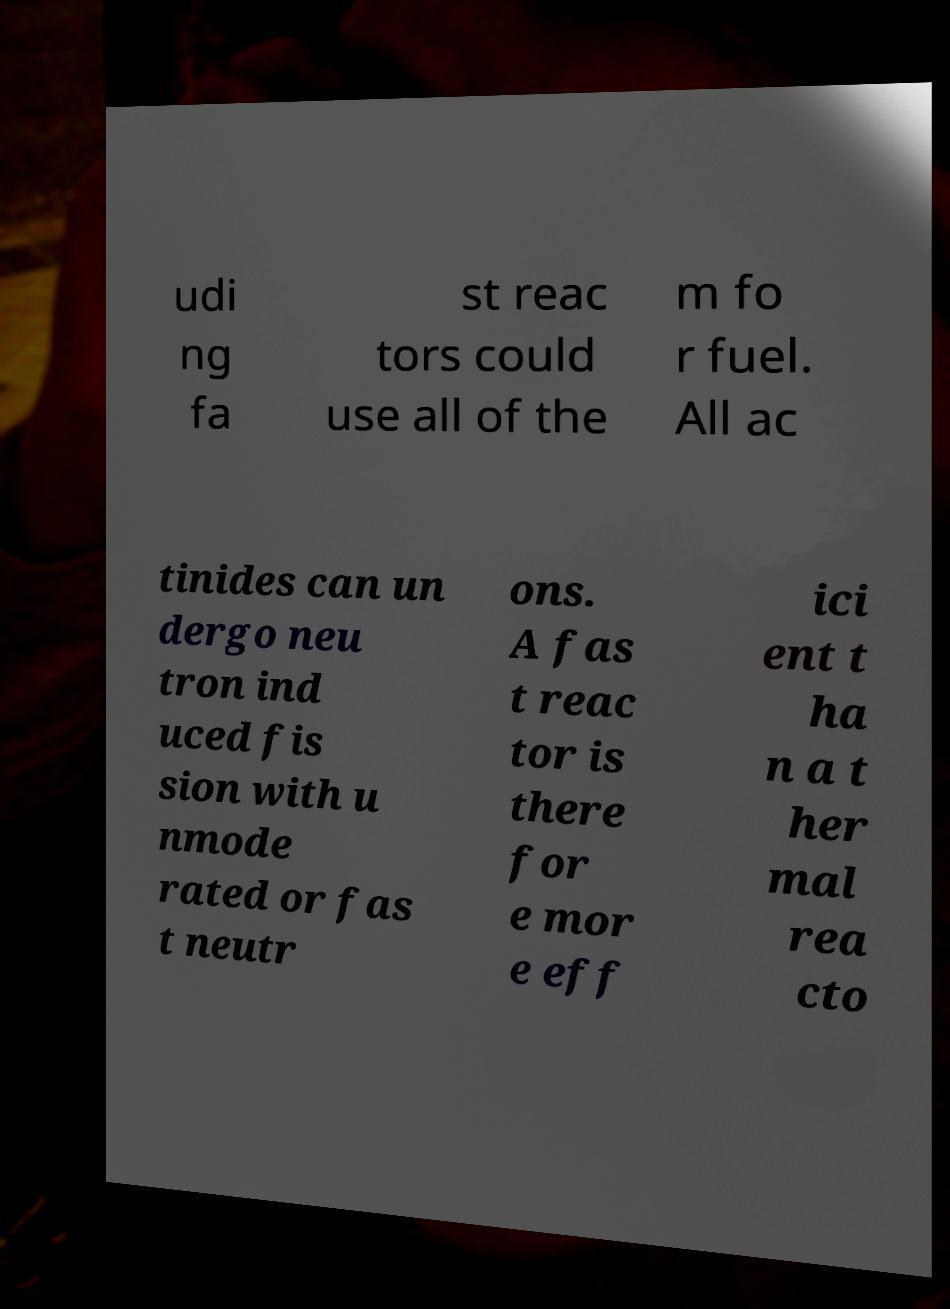There's text embedded in this image that I need extracted. Can you transcribe it verbatim? udi ng fa st reac tors could use all of the m fo r fuel. All ac tinides can un dergo neu tron ind uced fis sion with u nmode rated or fas t neutr ons. A fas t reac tor is there for e mor e eff ici ent t ha n a t her mal rea cto 